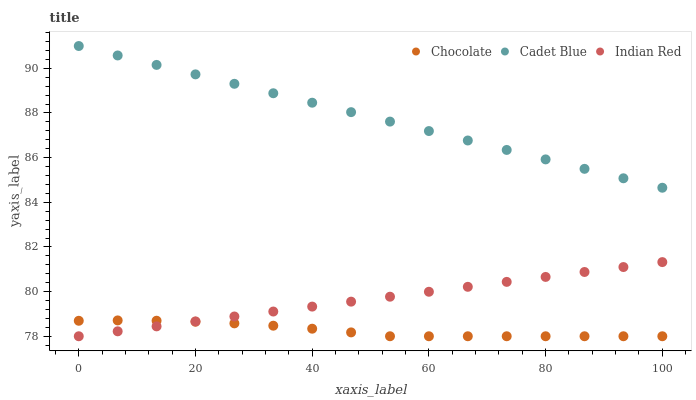Does Chocolate have the minimum area under the curve?
Answer yes or no. Yes. Does Cadet Blue have the maximum area under the curve?
Answer yes or no. Yes. Does Indian Red have the minimum area under the curve?
Answer yes or no. No. Does Indian Red have the maximum area under the curve?
Answer yes or no. No. Is Indian Red the smoothest?
Answer yes or no. Yes. Is Chocolate the roughest?
Answer yes or no. Yes. Is Chocolate the smoothest?
Answer yes or no. No. Is Indian Red the roughest?
Answer yes or no. No. Does Indian Red have the lowest value?
Answer yes or no. Yes. Does Cadet Blue have the highest value?
Answer yes or no. Yes. Does Indian Red have the highest value?
Answer yes or no. No. Is Indian Red less than Cadet Blue?
Answer yes or no. Yes. Is Cadet Blue greater than Indian Red?
Answer yes or no. Yes. Does Indian Red intersect Chocolate?
Answer yes or no. Yes. Is Indian Red less than Chocolate?
Answer yes or no. No. Is Indian Red greater than Chocolate?
Answer yes or no. No. Does Indian Red intersect Cadet Blue?
Answer yes or no. No. 